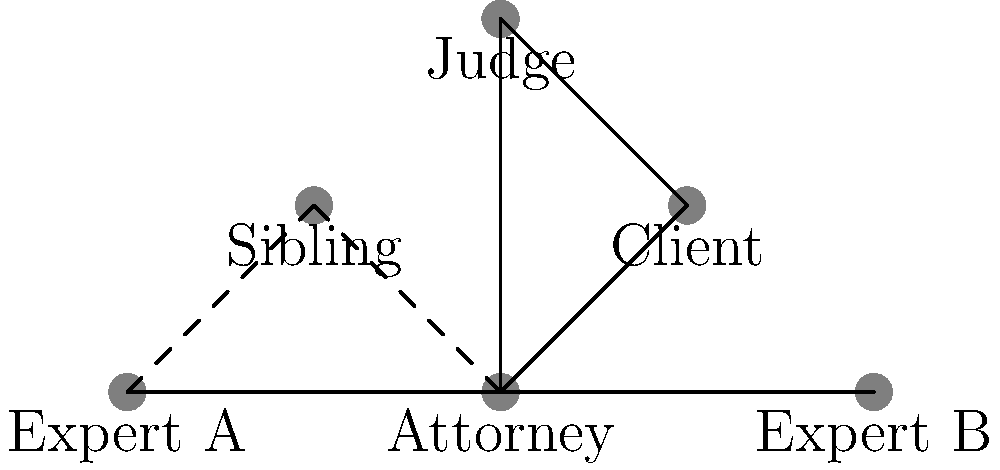In the network diagram representing a complex legal case, which stakeholder has the most direct connections, and how many connections does this stakeholder have? To answer this question, we need to analyze the connections in the network diagram:

1. Attorney:
   - Connected to Client
   - Connected to Sibling (dashed line, indicating a potential conflict)
   - Connected to Judge
   - Connected to Expert A
   - Connected to Expert B
   Total: 5 connections

2. Client:
   - Connected to Attorney
   - Connected to Judge
   Total: 2 connections

3. Sibling:
   - Connected to Attorney (dashed line)
   - Connected to Expert A (dashed line)
   Total: 2 connections

4. Judge:
   - Connected to Attorney
   - Connected to Client
   Total: 2 connections

5. Expert A:
   - Connected to Attorney
   - Connected to Sibling (dashed line)
   - Connected to Expert B
   Total: 3 connections

6. Expert B:
   - Connected to Attorney
   - Connected to Expert A
   Total: 2 connections

The stakeholder with the most direct connections is the Attorney, with 5 connections.
Answer: Attorney, 5 connections 